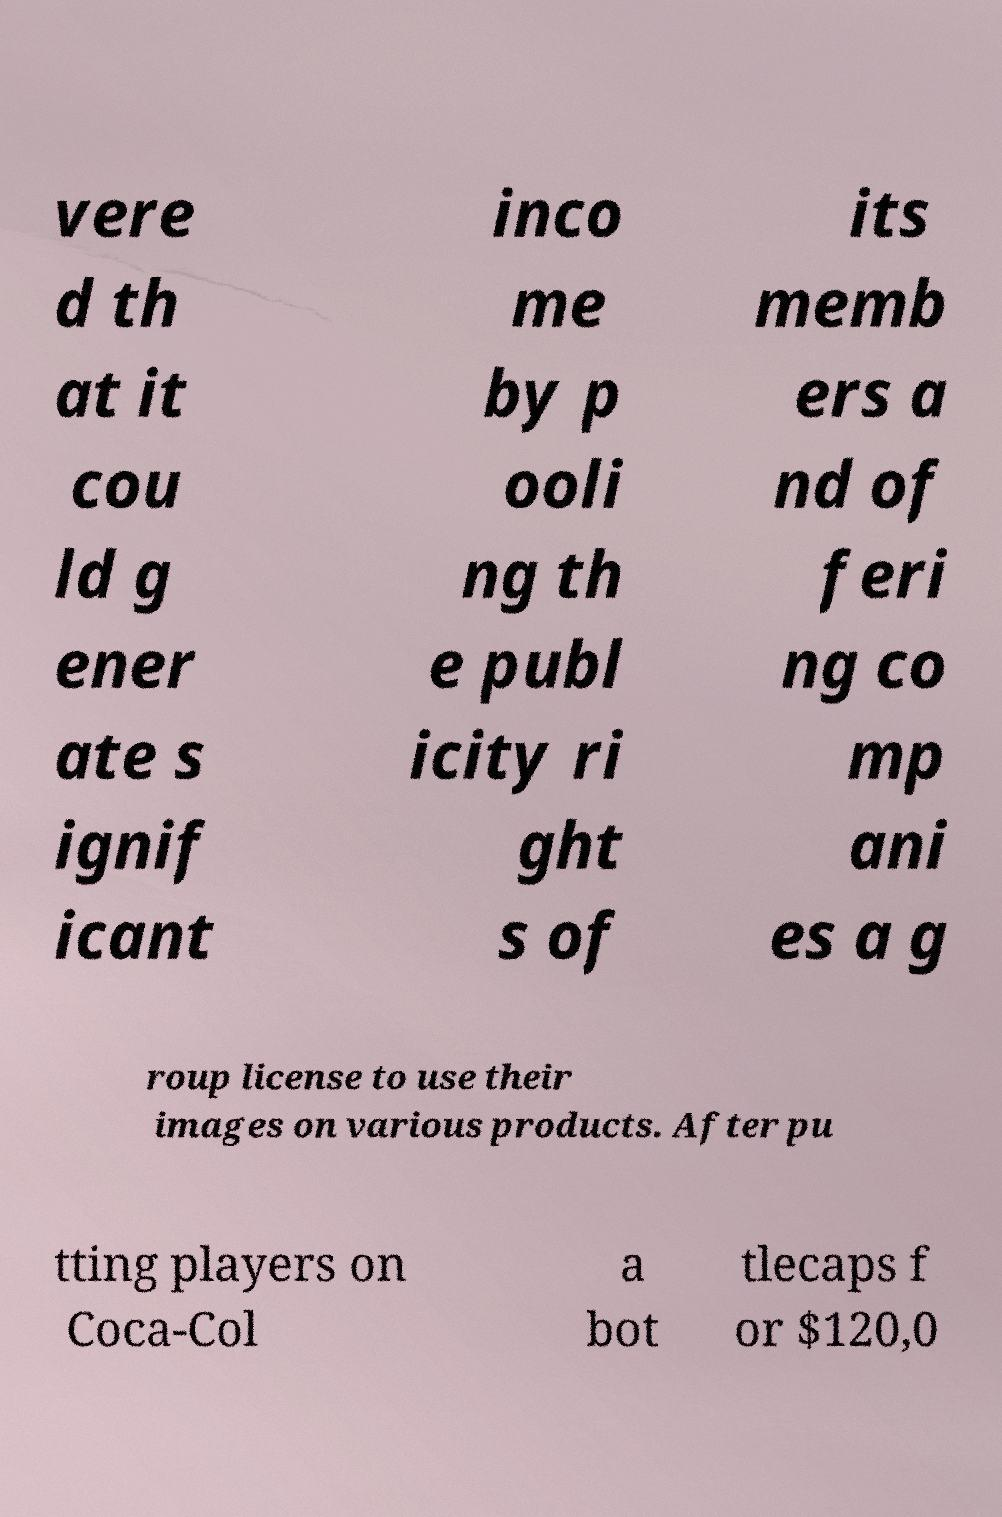For documentation purposes, I need the text within this image transcribed. Could you provide that? vere d th at it cou ld g ener ate s ignif icant inco me by p ooli ng th e publ icity ri ght s of its memb ers a nd of feri ng co mp ani es a g roup license to use their images on various products. After pu tting players on Coca-Col a bot tlecaps f or $120,0 